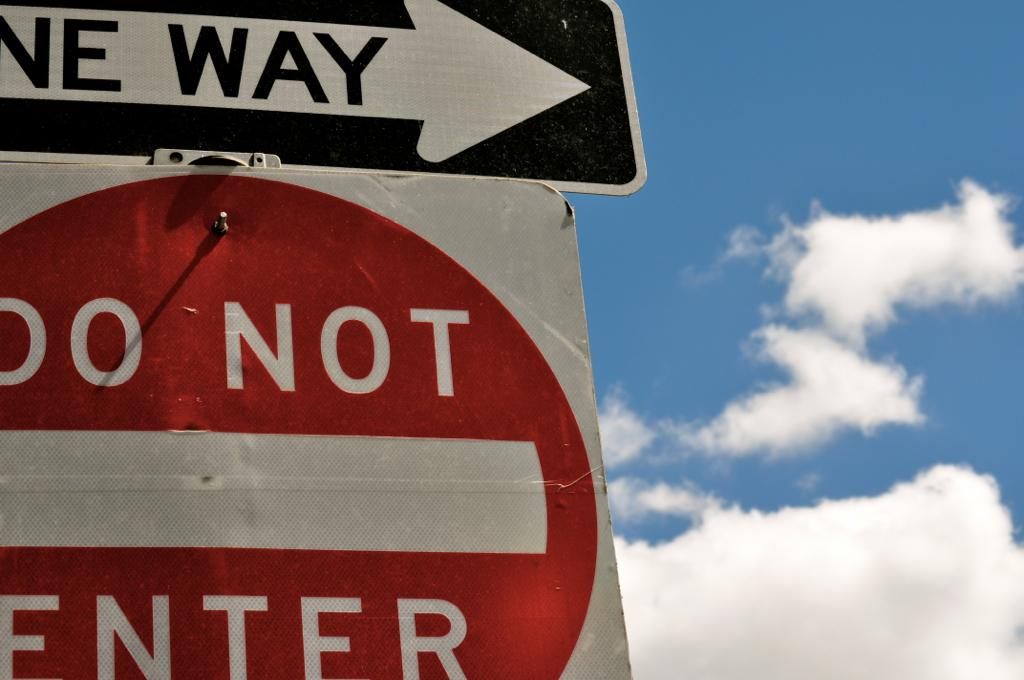Provide a one-sentence caption for the provided image. A One Way sign points the way above a red and white Do Not Enter sign. 